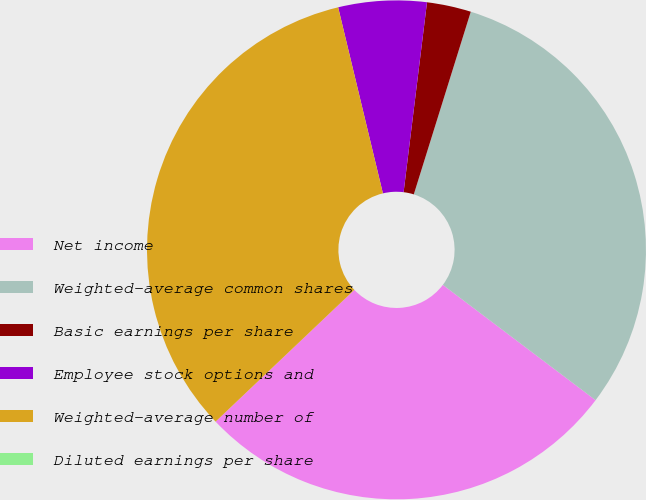Convert chart. <chart><loc_0><loc_0><loc_500><loc_500><pie_chart><fcel>Net income<fcel>Weighted-average common shares<fcel>Basic earnings per share<fcel>Employee stock options and<fcel>Weighted-average number of<fcel>Diluted earnings per share<nl><fcel>27.62%<fcel>30.48%<fcel>2.86%<fcel>5.71%<fcel>33.33%<fcel>0.0%<nl></chart> 